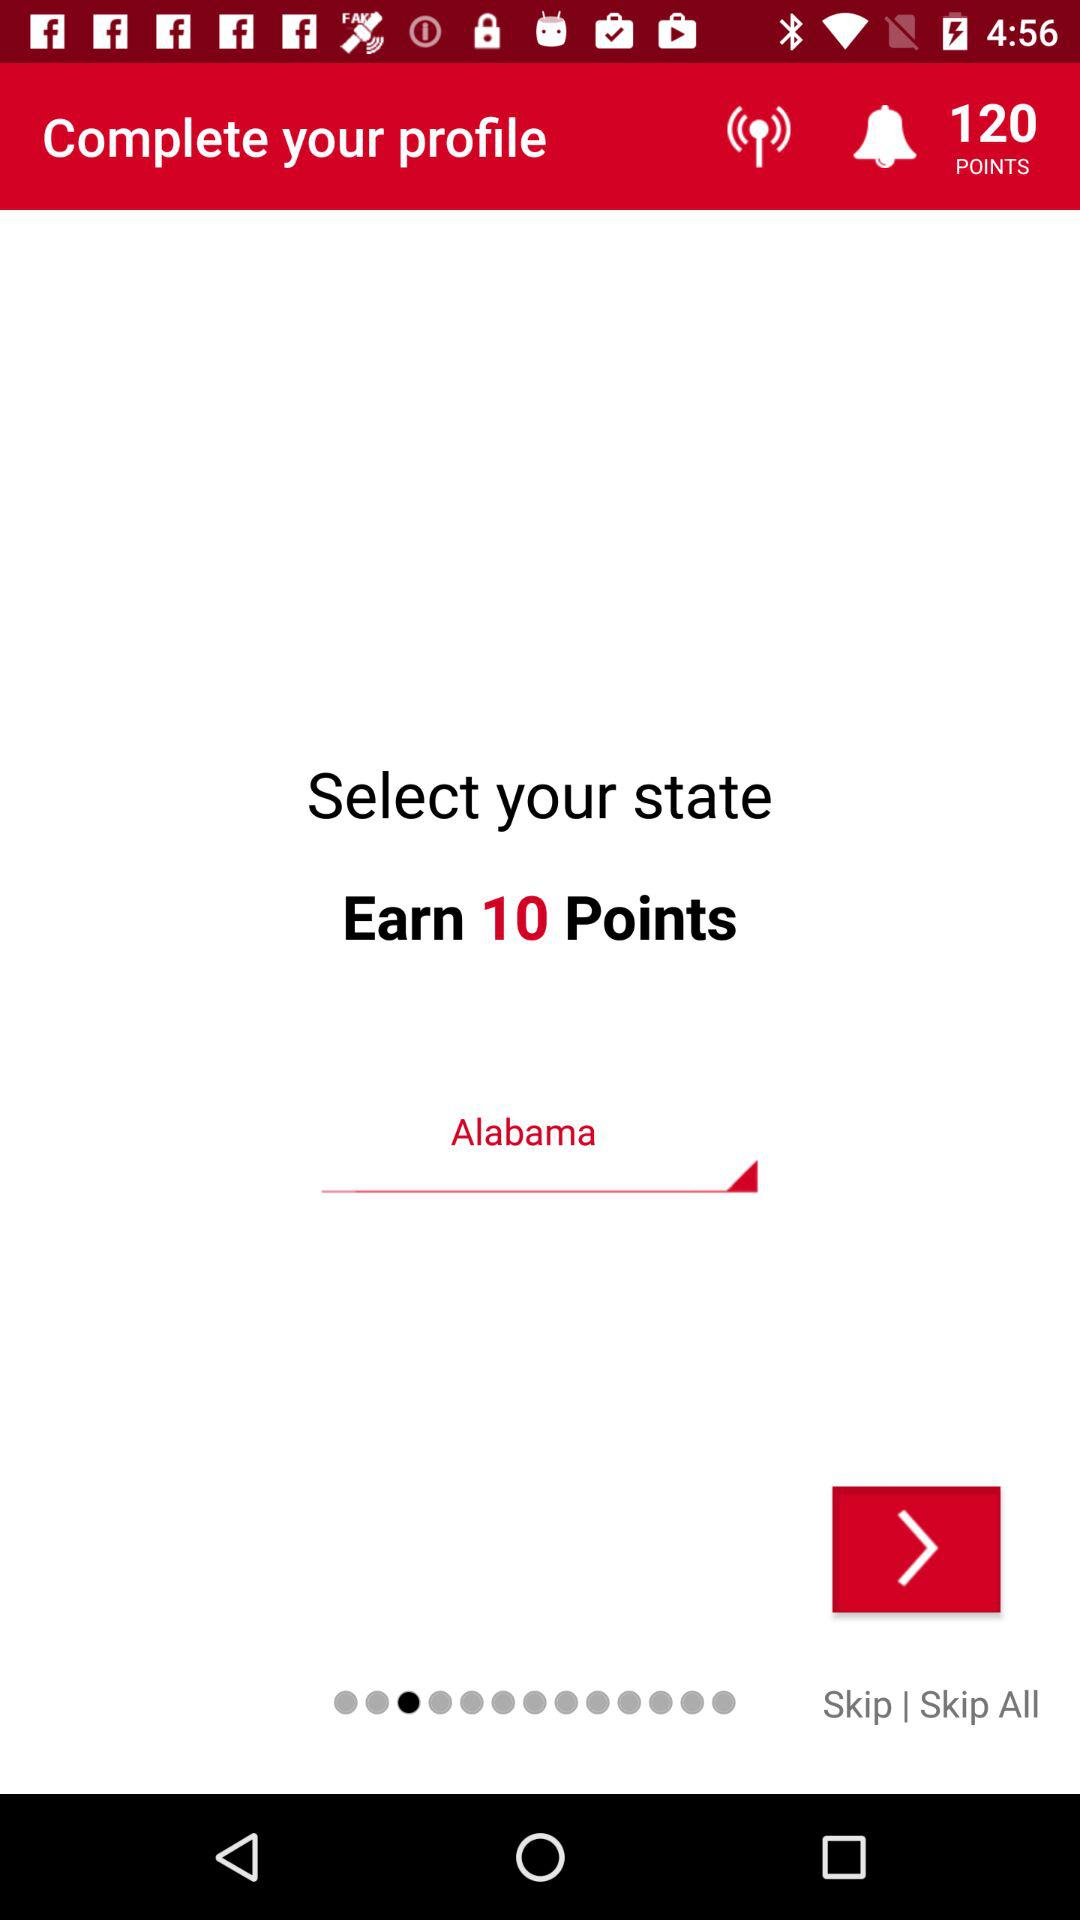What is the total number of points on the profile? The total number of points is 120. 